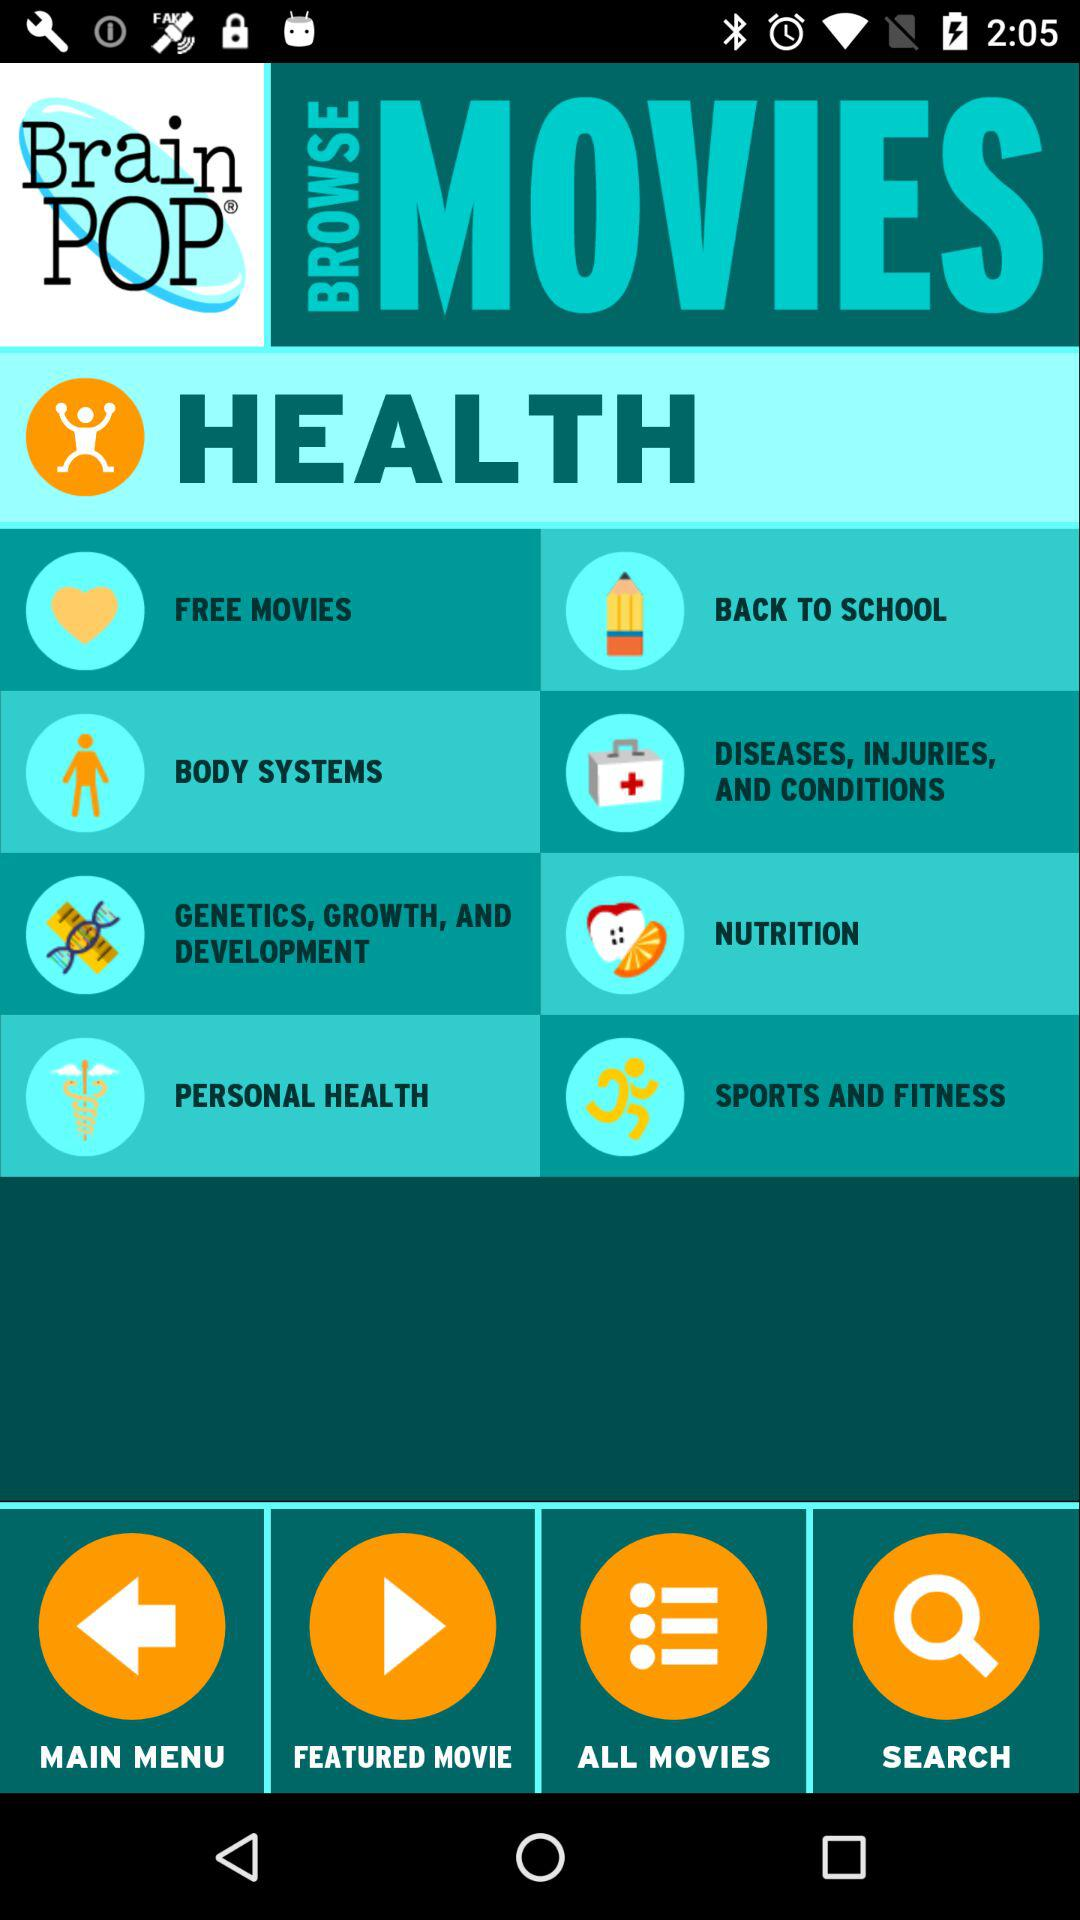What is the name of the application? The name of the application is "Brain POP". 